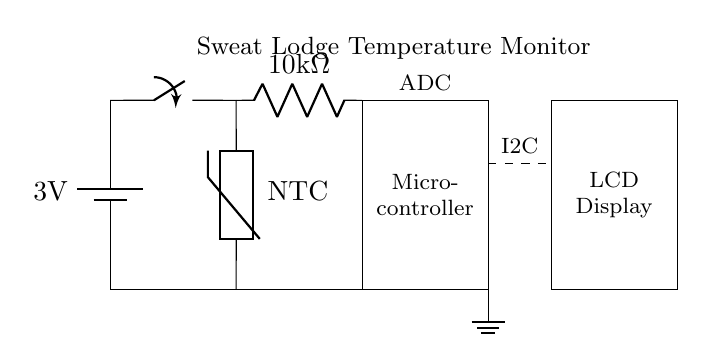What is the voltage of the battery? The circuit diagram indicates a battery with the label "3V," which shows the nominal voltage.
Answer: 3V What type of temperature sensor is used? The circuit diagram features a component labeled "NTC," indicating that it is a Negative Temperature Coefficient thermistor. This means that its resistance decreases with increasing temperature.
Answer: NTC How many resistors are present in the circuit? The circuit diagram shows one component labeled as a resistor in the circuit connected to the temperature sensor. The absence of any other resistors implies that only one resistor exists in this circuit.
Answer: 1 What is the function of the microcontroller in this circuit? The microcontroller's role, shown within the diagram, is to process signals from the temperature sensor and potentially control the output to the display. In more detail, it reads analog data from the thermistor and converts it into a digital format for display.
Answer: Signal processing What is the purpose of the I2C connection in the circuit? The I2C connection, indicated by the dashed line between the microcontroller and the display, is used for serial communication between these two components. This allows the microcontroller to send data, such as temperature readings, to the LCD display.
Answer: Serial communication What is the resistance value of the resistor in this circuit? In the circuit diagram, the resistor is labeled as "10kΩ," which specifies its resistance value. This value plays a role in determining how the thermistor reacts to temperature changes.
Answer: 10kΩ How is the circuit connected to ground? The circuit indicates a direct connection to ground through a line leading from the battery's negative terminal down to a ground symbol, establishing a common reference point for all voltage measurements in the circuit.
Answer: Directly 